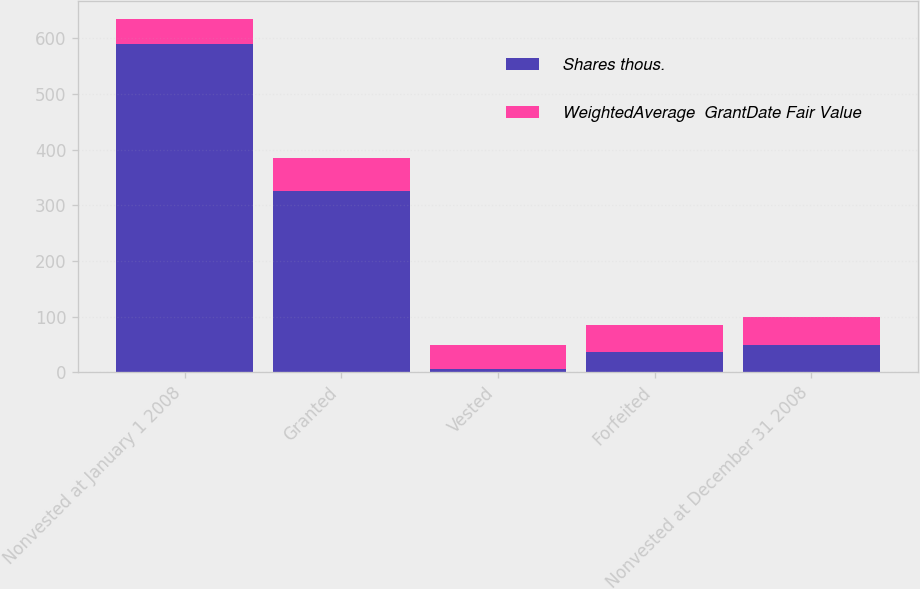Convert chart to OTSL. <chart><loc_0><loc_0><loc_500><loc_500><stacked_bar_chart><ecel><fcel>Nonvested at January 1 2008<fcel>Granted<fcel>Vested<fcel>Forfeited<fcel>Nonvested at December 31 2008<nl><fcel>Shares thous.<fcel>589<fcel>325<fcel>5<fcel>36<fcel>49.13<nl><fcel>WeightedAverage  GrantDate Fair Value<fcel>45.27<fcel>60.25<fcel>43.91<fcel>49.13<fcel>50.7<nl></chart> 